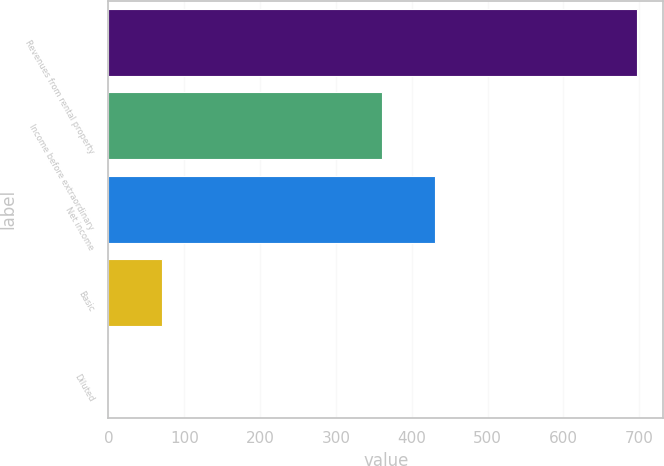Convert chart. <chart><loc_0><loc_0><loc_500><loc_500><bar_chart><fcel>Revenues from rental property<fcel>Income before extraordinary<fcel>Net income<fcel>Basic<fcel>Diluted<nl><fcel>696.6<fcel>361<fcel>430.53<fcel>70.86<fcel>1.33<nl></chart> 